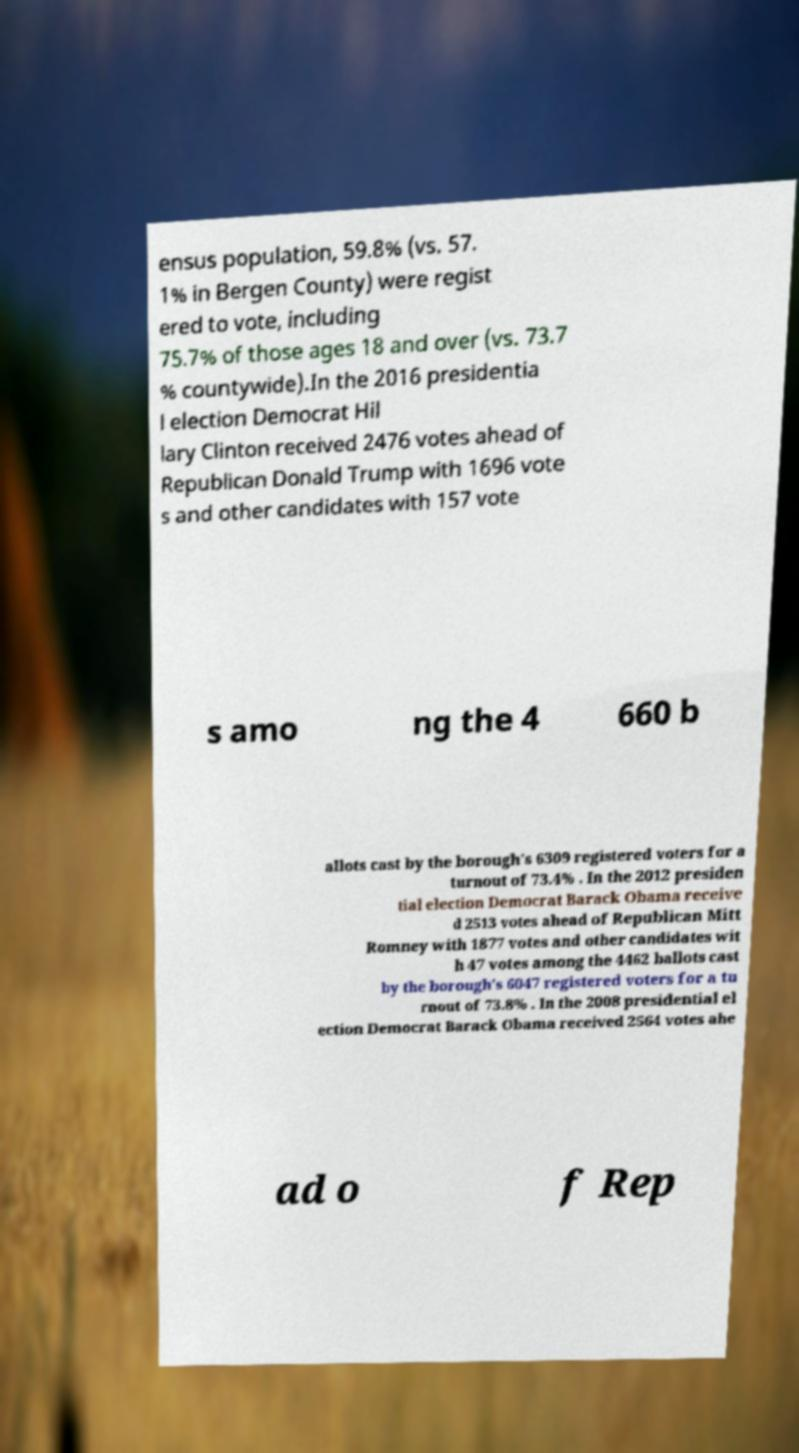Could you extract and type out the text from this image? ensus population, 59.8% (vs. 57. 1% in Bergen County) were regist ered to vote, including 75.7% of those ages 18 and over (vs. 73.7 % countywide).In the 2016 presidentia l election Democrat Hil lary Clinton received 2476 votes ahead of Republican Donald Trump with 1696 vote s and other candidates with 157 vote s amo ng the 4 660 b allots cast by the borough's 6309 registered voters for a turnout of 73.4% . In the 2012 presiden tial election Democrat Barack Obama receive d 2513 votes ahead of Republican Mitt Romney with 1877 votes and other candidates wit h 47 votes among the 4462 ballots cast by the borough's 6047 registered voters for a tu rnout of 73.8% . In the 2008 presidential el ection Democrat Barack Obama received 2564 votes ahe ad o f Rep 